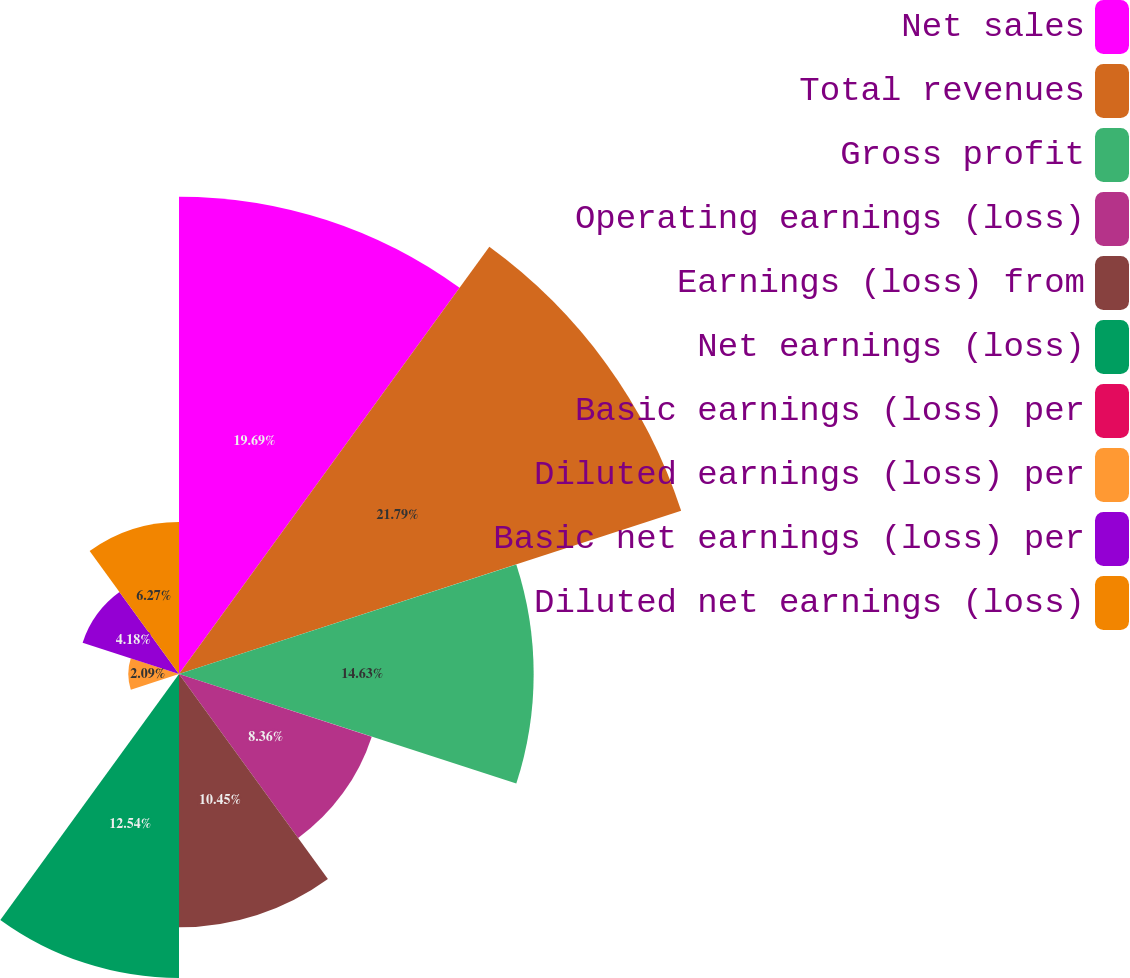Convert chart. <chart><loc_0><loc_0><loc_500><loc_500><pie_chart><fcel>Net sales<fcel>Total revenues<fcel>Gross profit<fcel>Operating earnings (loss)<fcel>Earnings (loss) from<fcel>Net earnings (loss)<fcel>Basic earnings (loss) per<fcel>Diluted earnings (loss) per<fcel>Basic net earnings (loss) per<fcel>Diluted net earnings (loss)<nl><fcel>19.69%<fcel>21.78%<fcel>14.63%<fcel>8.36%<fcel>10.45%<fcel>12.54%<fcel>0.0%<fcel>2.09%<fcel>4.18%<fcel>6.27%<nl></chart> 